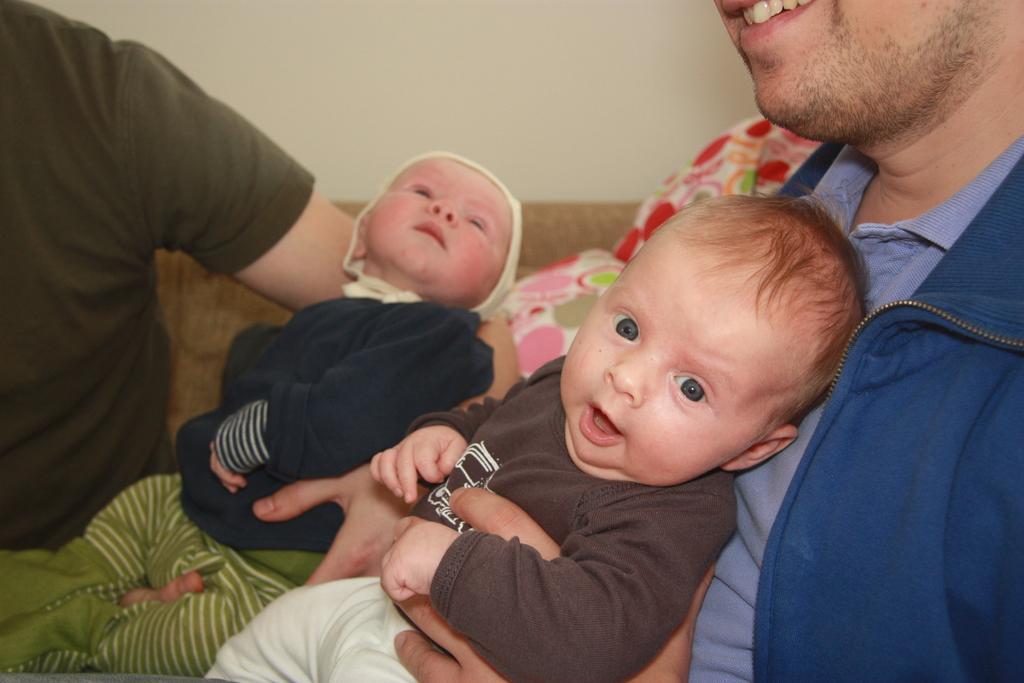Can you describe this image briefly? In this image we can see persons holding a babies. In the background there is a wall and sofa. 